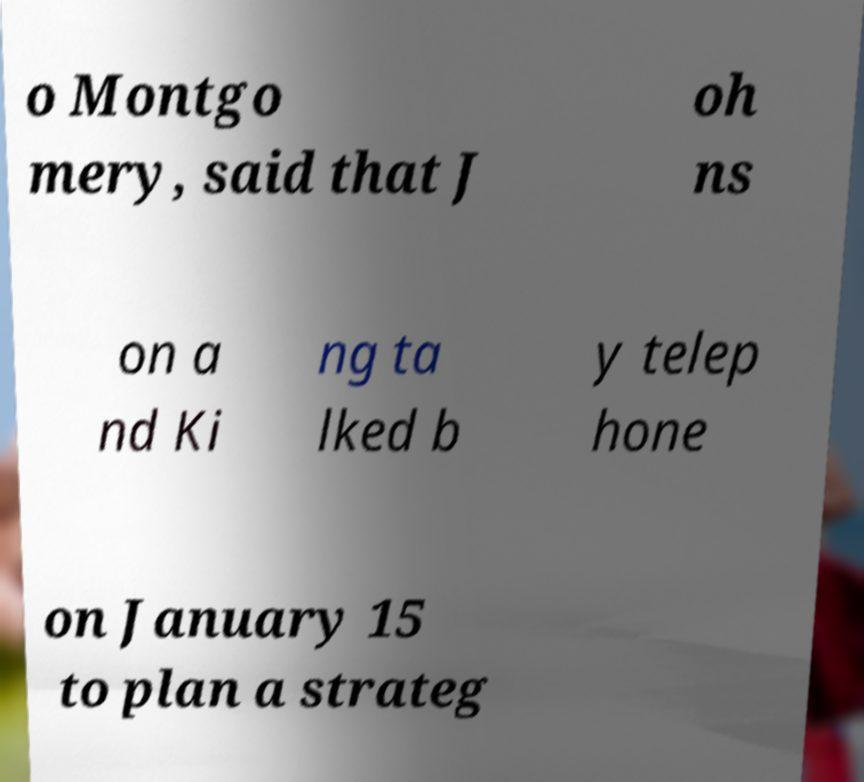There's text embedded in this image that I need extracted. Can you transcribe it verbatim? o Montgo mery, said that J oh ns on a nd Ki ng ta lked b y telep hone on January 15 to plan a strateg 